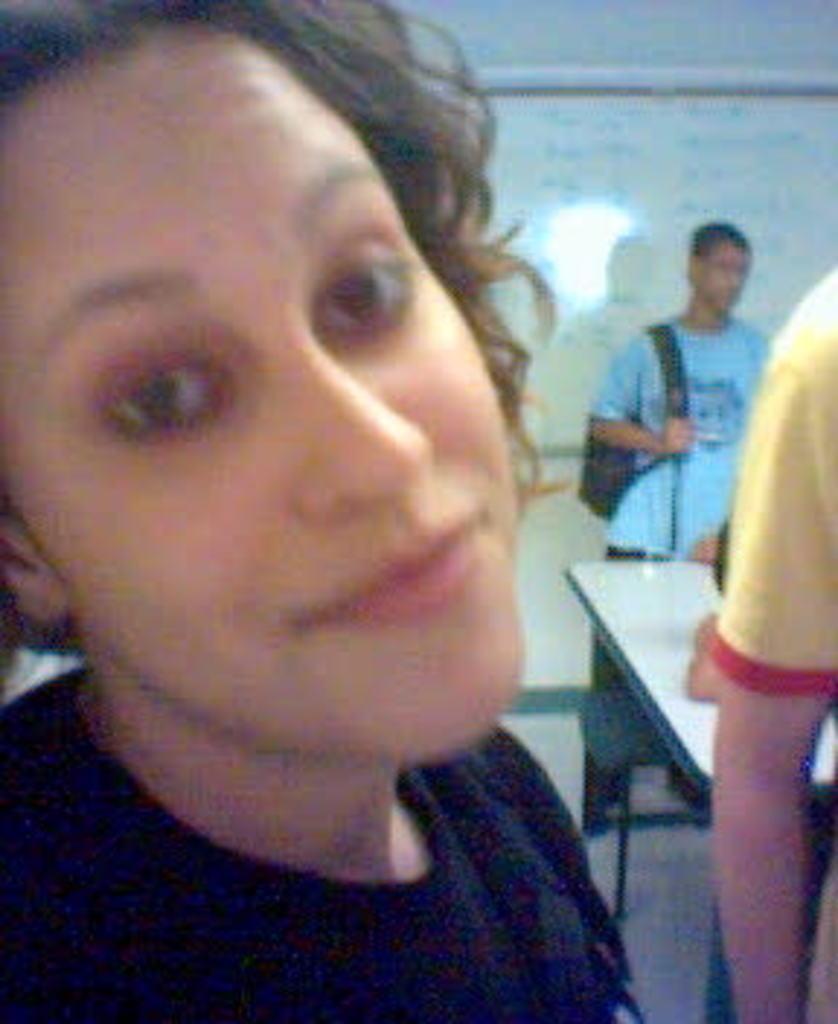How would you summarize this image in a sentence or two? In this image I can see few people with different color dresses and one person with the bag. To the right I can see the table. In the background I can see the board to the wall. 